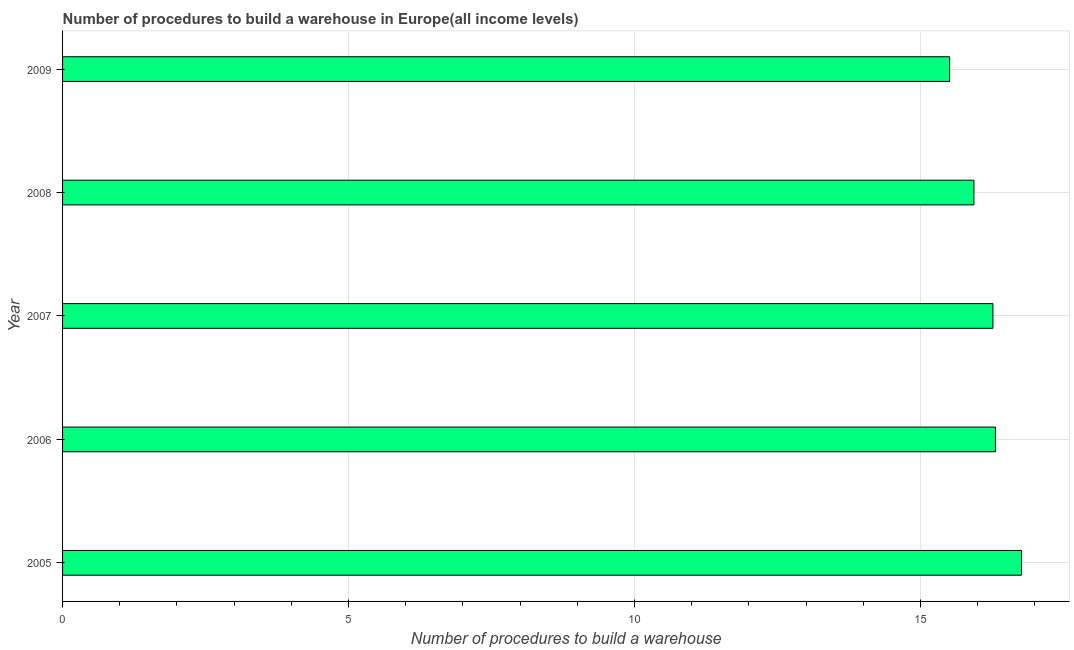Does the graph contain any zero values?
Provide a short and direct response. No. What is the title of the graph?
Give a very brief answer. Number of procedures to build a warehouse in Europe(all income levels). What is the label or title of the X-axis?
Offer a very short reply. Number of procedures to build a warehouse. What is the number of procedures to build a warehouse in 2006?
Keep it short and to the point. 16.31. Across all years, what is the maximum number of procedures to build a warehouse?
Make the answer very short. 16.77. Across all years, what is the minimum number of procedures to build a warehouse?
Offer a terse response. 15.51. In which year was the number of procedures to build a warehouse maximum?
Offer a terse response. 2005. What is the sum of the number of procedures to build a warehouse?
Your answer should be very brief. 80.79. What is the difference between the number of procedures to build a warehouse in 2006 and 2007?
Your answer should be compact. 0.04. What is the average number of procedures to build a warehouse per year?
Provide a succinct answer. 16.16. What is the median number of procedures to build a warehouse?
Provide a short and direct response. 16.27. What is the ratio of the number of procedures to build a warehouse in 2006 to that in 2009?
Provide a short and direct response. 1.05. Is the number of procedures to build a warehouse in 2007 less than that in 2008?
Your response must be concise. No. What is the difference between the highest and the second highest number of procedures to build a warehouse?
Your answer should be very brief. 0.46. Is the sum of the number of procedures to build a warehouse in 2007 and 2009 greater than the maximum number of procedures to build a warehouse across all years?
Provide a succinct answer. Yes. What is the difference between the highest and the lowest number of procedures to build a warehouse?
Your answer should be compact. 1.26. What is the difference between two consecutive major ticks on the X-axis?
Ensure brevity in your answer.  5. Are the values on the major ticks of X-axis written in scientific E-notation?
Make the answer very short. No. What is the Number of procedures to build a warehouse of 2005?
Provide a short and direct response. 16.77. What is the Number of procedures to build a warehouse of 2006?
Ensure brevity in your answer.  16.31. What is the Number of procedures to build a warehouse in 2007?
Your answer should be very brief. 16.27. What is the Number of procedures to build a warehouse of 2008?
Keep it short and to the point. 15.93. What is the Number of procedures to build a warehouse in 2009?
Keep it short and to the point. 15.51. What is the difference between the Number of procedures to build a warehouse in 2005 and 2006?
Provide a short and direct response. 0.46. What is the difference between the Number of procedures to build a warehouse in 2005 and 2007?
Your answer should be very brief. 0.5. What is the difference between the Number of procedures to build a warehouse in 2005 and 2008?
Offer a terse response. 0.83. What is the difference between the Number of procedures to build a warehouse in 2005 and 2009?
Your answer should be very brief. 1.26. What is the difference between the Number of procedures to build a warehouse in 2006 and 2007?
Your answer should be compact. 0.04. What is the difference between the Number of procedures to build a warehouse in 2006 and 2008?
Make the answer very short. 0.38. What is the difference between the Number of procedures to build a warehouse in 2006 and 2009?
Offer a terse response. 0.8. What is the difference between the Number of procedures to build a warehouse in 2007 and 2008?
Keep it short and to the point. 0.33. What is the difference between the Number of procedures to build a warehouse in 2007 and 2009?
Give a very brief answer. 0.76. What is the difference between the Number of procedures to build a warehouse in 2008 and 2009?
Provide a succinct answer. 0.42. What is the ratio of the Number of procedures to build a warehouse in 2005 to that in 2006?
Give a very brief answer. 1.03. What is the ratio of the Number of procedures to build a warehouse in 2005 to that in 2007?
Your response must be concise. 1.03. What is the ratio of the Number of procedures to build a warehouse in 2005 to that in 2008?
Your answer should be compact. 1.05. What is the ratio of the Number of procedures to build a warehouse in 2005 to that in 2009?
Your answer should be compact. 1.08. What is the ratio of the Number of procedures to build a warehouse in 2006 to that in 2008?
Provide a succinct answer. 1.02. What is the ratio of the Number of procedures to build a warehouse in 2006 to that in 2009?
Ensure brevity in your answer.  1.05. What is the ratio of the Number of procedures to build a warehouse in 2007 to that in 2008?
Offer a terse response. 1.02. What is the ratio of the Number of procedures to build a warehouse in 2007 to that in 2009?
Make the answer very short. 1.05. 